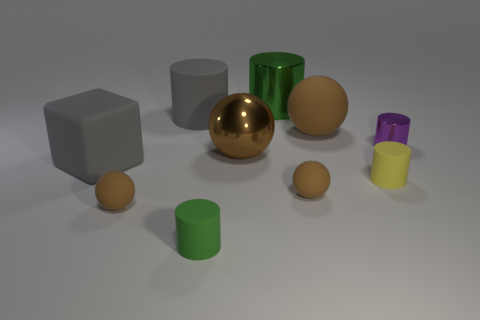Subtract all big cylinders. How many cylinders are left? 3 Subtract all yellow cylinders. How many cylinders are left? 4 Subtract all balls. How many objects are left? 6 Subtract 2 balls. How many balls are left? 2 Subtract all blue cubes. How many blue cylinders are left? 0 Subtract all brown shiny objects. Subtract all tiny purple shiny things. How many objects are left? 8 Add 1 gray matte cubes. How many gray matte cubes are left? 2 Add 4 red cubes. How many red cubes exist? 4 Subtract 0 cyan spheres. How many objects are left? 10 Subtract all green blocks. Subtract all brown cylinders. How many blocks are left? 1 